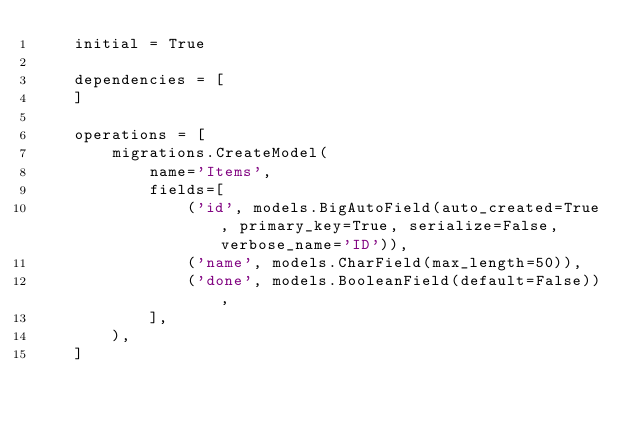<code> <loc_0><loc_0><loc_500><loc_500><_Python_>    initial = True

    dependencies = [
    ]

    operations = [
        migrations.CreateModel(
            name='Items',
            fields=[
                ('id', models.BigAutoField(auto_created=True, primary_key=True, serialize=False, verbose_name='ID')),
                ('name', models.CharField(max_length=50)),
                ('done', models.BooleanField(default=False)),
            ],
        ),
    ]
</code> 